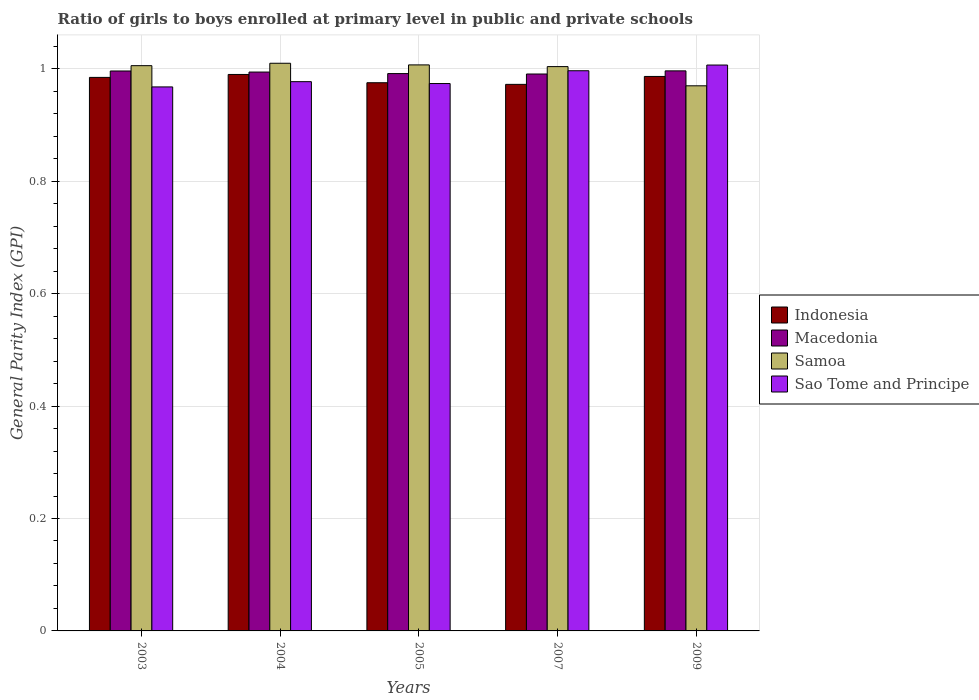How many different coloured bars are there?
Keep it short and to the point. 4. How many groups of bars are there?
Provide a succinct answer. 5. Are the number of bars on each tick of the X-axis equal?
Provide a short and direct response. Yes. How many bars are there on the 5th tick from the right?
Ensure brevity in your answer.  4. What is the label of the 5th group of bars from the left?
Keep it short and to the point. 2009. What is the general parity index in Sao Tome and Principe in 2007?
Your response must be concise. 1. Across all years, what is the maximum general parity index in Indonesia?
Offer a very short reply. 0.99. Across all years, what is the minimum general parity index in Macedonia?
Ensure brevity in your answer.  0.99. In which year was the general parity index in Samoa minimum?
Keep it short and to the point. 2009. What is the total general parity index in Indonesia in the graph?
Offer a very short reply. 4.91. What is the difference between the general parity index in Samoa in 2004 and that in 2005?
Your answer should be compact. 0. What is the difference between the general parity index in Indonesia in 2003 and the general parity index in Sao Tome and Principe in 2004?
Your answer should be very brief. 0.01. What is the average general parity index in Indonesia per year?
Your response must be concise. 0.98. In the year 2005, what is the difference between the general parity index in Sao Tome and Principe and general parity index in Samoa?
Ensure brevity in your answer.  -0.03. What is the ratio of the general parity index in Sao Tome and Principe in 2003 to that in 2004?
Your answer should be compact. 0.99. What is the difference between the highest and the second highest general parity index in Sao Tome and Principe?
Keep it short and to the point. 0.01. What is the difference between the highest and the lowest general parity index in Macedonia?
Keep it short and to the point. 0.01. In how many years, is the general parity index in Samoa greater than the average general parity index in Samoa taken over all years?
Ensure brevity in your answer.  4. What does the 4th bar from the left in 2003 represents?
Offer a terse response. Sao Tome and Principe. What does the 4th bar from the right in 2009 represents?
Give a very brief answer. Indonesia. How many bars are there?
Your answer should be compact. 20. Are all the bars in the graph horizontal?
Your answer should be very brief. No. Are the values on the major ticks of Y-axis written in scientific E-notation?
Give a very brief answer. No. Does the graph contain grids?
Give a very brief answer. Yes. How many legend labels are there?
Your answer should be very brief. 4. What is the title of the graph?
Ensure brevity in your answer.  Ratio of girls to boys enrolled at primary level in public and private schools. What is the label or title of the X-axis?
Offer a very short reply. Years. What is the label or title of the Y-axis?
Provide a short and direct response. General Parity Index (GPI). What is the General Parity Index (GPI) of Indonesia in 2003?
Make the answer very short. 0.98. What is the General Parity Index (GPI) in Macedonia in 2003?
Ensure brevity in your answer.  1. What is the General Parity Index (GPI) in Samoa in 2003?
Provide a succinct answer. 1.01. What is the General Parity Index (GPI) in Sao Tome and Principe in 2003?
Provide a short and direct response. 0.97. What is the General Parity Index (GPI) of Indonesia in 2004?
Your answer should be compact. 0.99. What is the General Parity Index (GPI) in Macedonia in 2004?
Provide a succinct answer. 0.99. What is the General Parity Index (GPI) in Samoa in 2004?
Your answer should be very brief. 1.01. What is the General Parity Index (GPI) of Sao Tome and Principe in 2004?
Provide a succinct answer. 0.98. What is the General Parity Index (GPI) of Indonesia in 2005?
Give a very brief answer. 0.98. What is the General Parity Index (GPI) of Macedonia in 2005?
Give a very brief answer. 0.99. What is the General Parity Index (GPI) of Samoa in 2005?
Offer a very short reply. 1.01. What is the General Parity Index (GPI) in Sao Tome and Principe in 2005?
Make the answer very short. 0.97. What is the General Parity Index (GPI) of Indonesia in 2007?
Offer a very short reply. 0.97. What is the General Parity Index (GPI) in Macedonia in 2007?
Keep it short and to the point. 0.99. What is the General Parity Index (GPI) in Samoa in 2007?
Offer a terse response. 1. What is the General Parity Index (GPI) of Sao Tome and Principe in 2007?
Give a very brief answer. 1. What is the General Parity Index (GPI) in Indonesia in 2009?
Your response must be concise. 0.99. What is the General Parity Index (GPI) in Macedonia in 2009?
Offer a very short reply. 1. What is the General Parity Index (GPI) of Samoa in 2009?
Your answer should be compact. 0.97. What is the General Parity Index (GPI) of Sao Tome and Principe in 2009?
Your response must be concise. 1.01. Across all years, what is the maximum General Parity Index (GPI) in Indonesia?
Offer a very short reply. 0.99. Across all years, what is the maximum General Parity Index (GPI) in Macedonia?
Provide a succinct answer. 1. Across all years, what is the maximum General Parity Index (GPI) of Samoa?
Your response must be concise. 1.01. Across all years, what is the maximum General Parity Index (GPI) of Sao Tome and Principe?
Ensure brevity in your answer.  1.01. Across all years, what is the minimum General Parity Index (GPI) in Indonesia?
Your response must be concise. 0.97. Across all years, what is the minimum General Parity Index (GPI) of Macedonia?
Keep it short and to the point. 0.99. Across all years, what is the minimum General Parity Index (GPI) of Samoa?
Provide a succinct answer. 0.97. Across all years, what is the minimum General Parity Index (GPI) of Sao Tome and Principe?
Make the answer very short. 0.97. What is the total General Parity Index (GPI) in Indonesia in the graph?
Give a very brief answer. 4.91. What is the total General Parity Index (GPI) in Macedonia in the graph?
Your answer should be very brief. 4.97. What is the total General Parity Index (GPI) of Samoa in the graph?
Make the answer very short. 5. What is the total General Parity Index (GPI) of Sao Tome and Principe in the graph?
Offer a terse response. 4.92. What is the difference between the General Parity Index (GPI) in Indonesia in 2003 and that in 2004?
Make the answer very short. -0.01. What is the difference between the General Parity Index (GPI) of Macedonia in 2003 and that in 2004?
Your answer should be compact. 0. What is the difference between the General Parity Index (GPI) of Samoa in 2003 and that in 2004?
Your answer should be very brief. -0. What is the difference between the General Parity Index (GPI) in Sao Tome and Principe in 2003 and that in 2004?
Provide a short and direct response. -0.01. What is the difference between the General Parity Index (GPI) of Indonesia in 2003 and that in 2005?
Your answer should be very brief. 0.01. What is the difference between the General Parity Index (GPI) in Macedonia in 2003 and that in 2005?
Keep it short and to the point. 0. What is the difference between the General Parity Index (GPI) of Samoa in 2003 and that in 2005?
Provide a short and direct response. -0. What is the difference between the General Parity Index (GPI) of Sao Tome and Principe in 2003 and that in 2005?
Keep it short and to the point. -0.01. What is the difference between the General Parity Index (GPI) in Indonesia in 2003 and that in 2007?
Ensure brevity in your answer.  0.01. What is the difference between the General Parity Index (GPI) in Macedonia in 2003 and that in 2007?
Give a very brief answer. 0.01. What is the difference between the General Parity Index (GPI) in Samoa in 2003 and that in 2007?
Offer a terse response. 0. What is the difference between the General Parity Index (GPI) of Sao Tome and Principe in 2003 and that in 2007?
Provide a short and direct response. -0.03. What is the difference between the General Parity Index (GPI) in Indonesia in 2003 and that in 2009?
Your answer should be very brief. -0. What is the difference between the General Parity Index (GPI) of Macedonia in 2003 and that in 2009?
Keep it short and to the point. -0. What is the difference between the General Parity Index (GPI) in Samoa in 2003 and that in 2009?
Offer a terse response. 0.04. What is the difference between the General Parity Index (GPI) of Sao Tome and Principe in 2003 and that in 2009?
Keep it short and to the point. -0.04. What is the difference between the General Parity Index (GPI) of Indonesia in 2004 and that in 2005?
Your response must be concise. 0.01. What is the difference between the General Parity Index (GPI) in Macedonia in 2004 and that in 2005?
Your response must be concise. 0. What is the difference between the General Parity Index (GPI) of Samoa in 2004 and that in 2005?
Offer a very short reply. 0. What is the difference between the General Parity Index (GPI) of Sao Tome and Principe in 2004 and that in 2005?
Your response must be concise. 0. What is the difference between the General Parity Index (GPI) of Indonesia in 2004 and that in 2007?
Offer a terse response. 0.02. What is the difference between the General Parity Index (GPI) of Macedonia in 2004 and that in 2007?
Offer a terse response. 0. What is the difference between the General Parity Index (GPI) of Samoa in 2004 and that in 2007?
Ensure brevity in your answer.  0.01. What is the difference between the General Parity Index (GPI) of Sao Tome and Principe in 2004 and that in 2007?
Make the answer very short. -0.02. What is the difference between the General Parity Index (GPI) in Indonesia in 2004 and that in 2009?
Keep it short and to the point. 0. What is the difference between the General Parity Index (GPI) in Macedonia in 2004 and that in 2009?
Keep it short and to the point. -0. What is the difference between the General Parity Index (GPI) of Samoa in 2004 and that in 2009?
Provide a succinct answer. 0.04. What is the difference between the General Parity Index (GPI) in Sao Tome and Principe in 2004 and that in 2009?
Make the answer very short. -0.03. What is the difference between the General Parity Index (GPI) in Indonesia in 2005 and that in 2007?
Offer a very short reply. 0. What is the difference between the General Parity Index (GPI) in Macedonia in 2005 and that in 2007?
Make the answer very short. 0. What is the difference between the General Parity Index (GPI) of Samoa in 2005 and that in 2007?
Ensure brevity in your answer.  0. What is the difference between the General Parity Index (GPI) of Sao Tome and Principe in 2005 and that in 2007?
Ensure brevity in your answer.  -0.02. What is the difference between the General Parity Index (GPI) in Indonesia in 2005 and that in 2009?
Provide a succinct answer. -0.01. What is the difference between the General Parity Index (GPI) in Macedonia in 2005 and that in 2009?
Your answer should be very brief. -0. What is the difference between the General Parity Index (GPI) in Samoa in 2005 and that in 2009?
Your answer should be compact. 0.04. What is the difference between the General Parity Index (GPI) of Sao Tome and Principe in 2005 and that in 2009?
Keep it short and to the point. -0.03. What is the difference between the General Parity Index (GPI) of Indonesia in 2007 and that in 2009?
Offer a very short reply. -0.01. What is the difference between the General Parity Index (GPI) in Macedonia in 2007 and that in 2009?
Offer a terse response. -0.01. What is the difference between the General Parity Index (GPI) of Samoa in 2007 and that in 2009?
Offer a terse response. 0.03. What is the difference between the General Parity Index (GPI) of Sao Tome and Principe in 2007 and that in 2009?
Keep it short and to the point. -0.01. What is the difference between the General Parity Index (GPI) in Indonesia in 2003 and the General Parity Index (GPI) in Macedonia in 2004?
Your response must be concise. -0.01. What is the difference between the General Parity Index (GPI) in Indonesia in 2003 and the General Parity Index (GPI) in Samoa in 2004?
Your answer should be compact. -0.03. What is the difference between the General Parity Index (GPI) of Indonesia in 2003 and the General Parity Index (GPI) of Sao Tome and Principe in 2004?
Offer a very short reply. 0.01. What is the difference between the General Parity Index (GPI) in Macedonia in 2003 and the General Parity Index (GPI) in Samoa in 2004?
Give a very brief answer. -0.01. What is the difference between the General Parity Index (GPI) in Macedonia in 2003 and the General Parity Index (GPI) in Sao Tome and Principe in 2004?
Your response must be concise. 0.02. What is the difference between the General Parity Index (GPI) in Samoa in 2003 and the General Parity Index (GPI) in Sao Tome and Principe in 2004?
Ensure brevity in your answer.  0.03. What is the difference between the General Parity Index (GPI) in Indonesia in 2003 and the General Parity Index (GPI) in Macedonia in 2005?
Make the answer very short. -0.01. What is the difference between the General Parity Index (GPI) in Indonesia in 2003 and the General Parity Index (GPI) in Samoa in 2005?
Offer a terse response. -0.02. What is the difference between the General Parity Index (GPI) in Indonesia in 2003 and the General Parity Index (GPI) in Sao Tome and Principe in 2005?
Your answer should be very brief. 0.01. What is the difference between the General Parity Index (GPI) in Macedonia in 2003 and the General Parity Index (GPI) in Samoa in 2005?
Your answer should be compact. -0.01. What is the difference between the General Parity Index (GPI) in Macedonia in 2003 and the General Parity Index (GPI) in Sao Tome and Principe in 2005?
Provide a short and direct response. 0.02. What is the difference between the General Parity Index (GPI) of Samoa in 2003 and the General Parity Index (GPI) of Sao Tome and Principe in 2005?
Offer a very short reply. 0.03. What is the difference between the General Parity Index (GPI) in Indonesia in 2003 and the General Parity Index (GPI) in Macedonia in 2007?
Provide a short and direct response. -0.01. What is the difference between the General Parity Index (GPI) in Indonesia in 2003 and the General Parity Index (GPI) in Samoa in 2007?
Provide a short and direct response. -0.02. What is the difference between the General Parity Index (GPI) in Indonesia in 2003 and the General Parity Index (GPI) in Sao Tome and Principe in 2007?
Your answer should be very brief. -0.01. What is the difference between the General Parity Index (GPI) of Macedonia in 2003 and the General Parity Index (GPI) of Samoa in 2007?
Make the answer very short. -0.01. What is the difference between the General Parity Index (GPI) of Macedonia in 2003 and the General Parity Index (GPI) of Sao Tome and Principe in 2007?
Provide a short and direct response. -0. What is the difference between the General Parity Index (GPI) in Samoa in 2003 and the General Parity Index (GPI) in Sao Tome and Principe in 2007?
Your response must be concise. 0.01. What is the difference between the General Parity Index (GPI) in Indonesia in 2003 and the General Parity Index (GPI) in Macedonia in 2009?
Offer a very short reply. -0.01. What is the difference between the General Parity Index (GPI) of Indonesia in 2003 and the General Parity Index (GPI) of Samoa in 2009?
Ensure brevity in your answer.  0.01. What is the difference between the General Parity Index (GPI) in Indonesia in 2003 and the General Parity Index (GPI) in Sao Tome and Principe in 2009?
Provide a succinct answer. -0.02. What is the difference between the General Parity Index (GPI) in Macedonia in 2003 and the General Parity Index (GPI) in Samoa in 2009?
Provide a succinct answer. 0.03. What is the difference between the General Parity Index (GPI) of Macedonia in 2003 and the General Parity Index (GPI) of Sao Tome and Principe in 2009?
Offer a very short reply. -0.01. What is the difference between the General Parity Index (GPI) of Samoa in 2003 and the General Parity Index (GPI) of Sao Tome and Principe in 2009?
Your response must be concise. -0. What is the difference between the General Parity Index (GPI) of Indonesia in 2004 and the General Parity Index (GPI) of Macedonia in 2005?
Keep it short and to the point. -0. What is the difference between the General Parity Index (GPI) of Indonesia in 2004 and the General Parity Index (GPI) of Samoa in 2005?
Provide a short and direct response. -0.02. What is the difference between the General Parity Index (GPI) of Indonesia in 2004 and the General Parity Index (GPI) of Sao Tome and Principe in 2005?
Your response must be concise. 0.02. What is the difference between the General Parity Index (GPI) of Macedonia in 2004 and the General Parity Index (GPI) of Samoa in 2005?
Your answer should be compact. -0.01. What is the difference between the General Parity Index (GPI) in Macedonia in 2004 and the General Parity Index (GPI) in Sao Tome and Principe in 2005?
Your answer should be compact. 0.02. What is the difference between the General Parity Index (GPI) in Samoa in 2004 and the General Parity Index (GPI) in Sao Tome and Principe in 2005?
Your answer should be very brief. 0.04. What is the difference between the General Parity Index (GPI) in Indonesia in 2004 and the General Parity Index (GPI) in Macedonia in 2007?
Provide a short and direct response. -0. What is the difference between the General Parity Index (GPI) in Indonesia in 2004 and the General Parity Index (GPI) in Samoa in 2007?
Provide a short and direct response. -0.01. What is the difference between the General Parity Index (GPI) of Indonesia in 2004 and the General Parity Index (GPI) of Sao Tome and Principe in 2007?
Provide a short and direct response. -0.01. What is the difference between the General Parity Index (GPI) of Macedonia in 2004 and the General Parity Index (GPI) of Samoa in 2007?
Give a very brief answer. -0.01. What is the difference between the General Parity Index (GPI) of Macedonia in 2004 and the General Parity Index (GPI) of Sao Tome and Principe in 2007?
Your answer should be very brief. -0. What is the difference between the General Parity Index (GPI) in Samoa in 2004 and the General Parity Index (GPI) in Sao Tome and Principe in 2007?
Provide a short and direct response. 0.01. What is the difference between the General Parity Index (GPI) of Indonesia in 2004 and the General Parity Index (GPI) of Macedonia in 2009?
Make the answer very short. -0.01. What is the difference between the General Parity Index (GPI) in Indonesia in 2004 and the General Parity Index (GPI) in Samoa in 2009?
Your answer should be very brief. 0.02. What is the difference between the General Parity Index (GPI) in Indonesia in 2004 and the General Parity Index (GPI) in Sao Tome and Principe in 2009?
Your response must be concise. -0.02. What is the difference between the General Parity Index (GPI) of Macedonia in 2004 and the General Parity Index (GPI) of Samoa in 2009?
Offer a terse response. 0.02. What is the difference between the General Parity Index (GPI) of Macedonia in 2004 and the General Parity Index (GPI) of Sao Tome and Principe in 2009?
Provide a short and direct response. -0.01. What is the difference between the General Parity Index (GPI) of Samoa in 2004 and the General Parity Index (GPI) of Sao Tome and Principe in 2009?
Keep it short and to the point. 0. What is the difference between the General Parity Index (GPI) of Indonesia in 2005 and the General Parity Index (GPI) of Macedonia in 2007?
Make the answer very short. -0.02. What is the difference between the General Parity Index (GPI) of Indonesia in 2005 and the General Parity Index (GPI) of Samoa in 2007?
Make the answer very short. -0.03. What is the difference between the General Parity Index (GPI) of Indonesia in 2005 and the General Parity Index (GPI) of Sao Tome and Principe in 2007?
Provide a succinct answer. -0.02. What is the difference between the General Parity Index (GPI) in Macedonia in 2005 and the General Parity Index (GPI) in Samoa in 2007?
Your response must be concise. -0.01. What is the difference between the General Parity Index (GPI) of Macedonia in 2005 and the General Parity Index (GPI) of Sao Tome and Principe in 2007?
Provide a short and direct response. -0.01. What is the difference between the General Parity Index (GPI) in Samoa in 2005 and the General Parity Index (GPI) in Sao Tome and Principe in 2007?
Make the answer very short. 0.01. What is the difference between the General Parity Index (GPI) of Indonesia in 2005 and the General Parity Index (GPI) of Macedonia in 2009?
Provide a short and direct response. -0.02. What is the difference between the General Parity Index (GPI) of Indonesia in 2005 and the General Parity Index (GPI) of Samoa in 2009?
Keep it short and to the point. 0.01. What is the difference between the General Parity Index (GPI) in Indonesia in 2005 and the General Parity Index (GPI) in Sao Tome and Principe in 2009?
Make the answer very short. -0.03. What is the difference between the General Parity Index (GPI) of Macedonia in 2005 and the General Parity Index (GPI) of Samoa in 2009?
Your answer should be compact. 0.02. What is the difference between the General Parity Index (GPI) in Macedonia in 2005 and the General Parity Index (GPI) in Sao Tome and Principe in 2009?
Make the answer very short. -0.02. What is the difference between the General Parity Index (GPI) in Samoa in 2005 and the General Parity Index (GPI) in Sao Tome and Principe in 2009?
Keep it short and to the point. 0. What is the difference between the General Parity Index (GPI) in Indonesia in 2007 and the General Parity Index (GPI) in Macedonia in 2009?
Make the answer very short. -0.02. What is the difference between the General Parity Index (GPI) in Indonesia in 2007 and the General Parity Index (GPI) in Samoa in 2009?
Give a very brief answer. 0. What is the difference between the General Parity Index (GPI) of Indonesia in 2007 and the General Parity Index (GPI) of Sao Tome and Principe in 2009?
Offer a terse response. -0.03. What is the difference between the General Parity Index (GPI) of Macedonia in 2007 and the General Parity Index (GPI) of Samoa in 2009?
Make the answer very short. 0.02. What is the difference between the General Parity Index (GPI) of Macedonia in 2007 and the General Parity Index (GPI) of Sao Tome and Principe in 2009?
Ensure brevity in your answer.  -0.02. What is the difference between the General Parity Index (GPI) in Samoa in 2007 and the General Parity Index (GPI) in Sao Tome and Principe in 2009?
Provide a short and direct response. -0. What is the average General Parity Index (GPI) of Indonesia per year?
Keep it short and to the point. 0.98. What is the average General Parity Index (GPI) of Macedonia per year?
Offer a very short reply. 0.99. What is the average General Parity Index (GPI) in Samoa per year?
Offer a very short reply. 1. What is the average General Parity Index (GPI) of Sao Tome and Principe per year?
Your answer should be compact. 0.98. In the year 2003, what is the difference between the General Parity Index (GPI) of Indonesia and General Parity Index (GPI) of Macedonia?
Provide a succinct answer. -0.01. In the year 2003, what is the difference between the General Parity Index (GPI) of Indonesia and General Parity Index (GPI) of Samoa?
Give a very brief answer. -0.02. In the year 2003, what is the difference between the General Parity Index (GPI) in Indonesia and General Parity Index (GPI) in Sao Tome and Principe?
Your answer should be very brief. 0.02. In the year 2003, what is the difference between the General Parity Index (GPI) of Macedonia and General Parity Index (GPI) of Samoa?
Offer a very short reply. -0.01. In the year 2003, what is the difference between the General Parity Index (GPI) in Macedonia and General Parity Index (GPI) in Sao Tome and Principe?
Your answer should be compact. 0.03. In the year 2003, what is the difference between the General Parity Index (GPI) in Samoa and General Parity Index (GPI) in Sao Tome and Principe?
Make the answer very short. 0.04. In the year 2004, what is the difference between the General Parity Index (GPI) of Indonesia and General Parity Index (GPI) of Macedonia?
Offer a terse response. -0. In the year 2004, what is the difference between the General Parity Index (GPI) in Indonesia and General Parity Index (GPI) in Samoa?
Ensure brevity in your answer.  -0.02. In the year 2004, what is the difference between the General Parity Index (GPI) in Indonesia and General Parity Index (GPI) in Sao Tome and Principe?
Provide a succinct answer. 0.01. In the year 2004, what is the difference between the General Parity Index (GPI) in Macedonia and General Parity Index (GPI) in Samoa?
Ensure brevity in your answer.  -0.02. In the year 2004, what is the difference between the General Parity Index (GPI) in Macedonia and General Parity Index (GPI) in Sao Tome and Principe?
Offer a very short reply. 0.02. In the year 2004, what is the difference between the General Parity Index (GPI) of Samoa and General Parity Index (GPI) of Sao Tome and Principe?
Your answer should be compact. 0.03. In the year 2005, what is the difference between the General Parity Index (GPI) of Indonesia and General Parity Index (GPI) of Macedonia?
Your response must be concise. -0.02. In the year 2005, what is the difference between the General Parity Index (GPI) in Indonesia and General Parity Index (GPI) in Samoa?
Provide a succinct answer. -0.03. In the year 2005, what is the difference between the General Parity Index (GPI) in Indonesia and General Parity Index (GPI) in Sao Tome and Principe?
Your answer should be very brief. 0. In the year 2005, what is the difference between the General Parity Index (GPI) in Macedonia and General Parity Index (GPI) in Samoa?
Your answer should be compact. -0.02. In the year 2005, what is the difference between the General Parity Index (GPI) of Macedonia and General Parity Index (GPI) of Sao Tome and Principe?
Make the answer very short. 0.02. In the year 2005, what is the difference between the General Parity Index (GPI) of Samoa and General Parity Index (GPI) of Sao Tome and Principe?
Offer a terse response. 0.03. In the year 2007, what is the difference between the General Parity Index (GPI) in Indonesia and General Parity Index (GPI) in Macedonia?
Make the answer very short. -0.02. In the year 2007, what is the difference between the General Parity Index (GPI) of Indonesia and General Parity Index (GPI) of Samoa?
Your answer should be very brief. -0.03. In the year 2007, what is the difference between the General Parity Index (GPI) in Indonesia and General Parity Index (GPI) in Sao Tome and Principe?
Offer a terse response. -0.02. In the year 2007, what is the difference between the General Parity Index (GPI) of Macedonia and General Parity Index (GPI) of Samoa?
Your answer should be compact. -0.01. In the year 2007, what is the difference between the General Parity Index (GPI) of Macedonia and General Parity Index (GPI) of Sao Tome and Principe?
Offer a terse response. -0.01. In the year 2007, what is the difference between the General Parity Index (GPI) in Samoa and General Parity Index (GPI) in Sao Tome and Principe?
Give a very brief answer. 0.01. In the year 2009, what is the difference between the General Parity Index (GPI) in Indonesia and General Parity Index (GPI) in Macedonia?
Ensure brevity in your answer.  -0.01. In the year 2009, what is the difference between the General Parity Index (GPI) in Indonesia and General Parity Index (GPI) in Samoa?
Ensure brevity in your answer.  0.02. In the year 2009, what is the difference between the General Parity Index (GPI) of Indonesia and General Parity Index (GPI) of Sao Tome and Principe?
Ensure brevity in your answer.  -0.02. In the year 2009, what is the difference between the General Parity Index (GPI) in Macedonia and General Parity Index (GPI) in Samoa?
Provide a short and direct response. 0.03. In the year 2009, what is the difference between the General Parity Index (GPI) of Macedonia and General Parity Index (GPI) of Sao Tome and Principe?
Give a very brief answer. -0.01. In the year 2009, what is the difference between the General Parity Index (GPI) of Samoa and General Parity Index (GPI) of Sao Tome and Principe?
Ensure brevity in your answer.  -0.04. What is the ratio of the General Parity Index (GPI) in Macedonia in 2003 to that in 2004?
Your answer should be very brief. 1. What is the ratio of the General Parity Index (GPI) of Sao Tome and Principe in 2003 to that in 2004?
Offer a very short reply. 0.99. What is the ratio of the General Parity Index (GPI) in Indonesia in 2003 to that in 2005?
Offer a terse response. 1.01. What is the ratio of the General Parity Index (GPI) of Macedonia in 2003 to that in 2005?
Provide a succinct answer. 1. What is the ratio of the General Parity Index (GPI) in Indonesia in 2003 to that in 2007?
Offer a very short reply. 1.01. What is the ratio of the General Parity Index (GPI) of Macedonia in 2003 to that in 2007?
Provide a short and direct response. 1.01. What is the ratio of the General Parity Index (GPI) of Sao Tome and Principe in 2003 to that in 2007?
Your response must be concise. 0.97. What is the ratio of the General Parity Index (GPI) in Indonesia in 2003 to that in 2009?
Your response must be concise. 1. What is the ratio of the General Parity Index (GPI) of Macedonia in 2003 to that in 2009?
Offer a very short reply. 1. What is the ratio of the General Parity Index (GPI) of Samoa in 2003 to that in 2009?
Give a very brief answer. 1.04. What is the ratio of the General Parity Index (GPI) of Sao Tome and Principe in 2003 to that in 2009?
Your answer should be compact. 0.96. What is the ratio of the General Parity Index (GPI) in Indonesia in 2004 to that in 2005?
Provide a succinct answer. 1.02. What is the ratio of the General Parity Index (GPI) of Macedonia in 2004 to that in 2005?
Your answer should be very brief. 1. What is the ratio of the General Parity Index (GPI) of Samoa in 2004 to that in 2005?
Ensure brevity in your answer.  1. What is the ratio of the General Parity Index (GPI) of Sao Tome and Principe in 2004 to that in 2005?
Give a very brief answer. 1. What is the ratio of the General Parity Index (GPI) in Indonesia in 2004 to that in 2007?
Offer a very short reply. 1.02. What is the ratio of the General Parity Index (GPI) of Macedonia in 2004 to that in 2007?
Give a very brief answer. 1. What is the ratio of the General Parity Index (GPI) in Samoa in 2004 to that in 2007?
Your answer should be compact. 1.01. What is the ratio of the General Parity Index (GPI) of Sao Tome and Principe in 2004 to that in 2007?
Ensure brevity in your answer.  0.98. What is the ratio of the General Parity Index (GPI) in Samoa in 2004 to that in 2009?
Make the answer very short. 1.04. What is the ratio of the General Parity Index (GPI) in Sao Tome and Principe in 2004 to that in 2009?
Offer a very short reply. 0.97. What is the ratio of the General Parity Index (GPI) of Indonesia in 2005 to that in 2007?
Your response must be concise. 1. What is the ratio of the General Parity Index (GPI) of Samoa in 2005 to that in 2007?
Offer a terse response. 1. What is the ratio of the General Parity Index (GPI) of Sao Tome and Principe in 2005 to that in 2007?
Keep it short and to the point. 0.98. What is the ratio of the General Parity Index (GPI) of Indonesia in 2005 to that in 2009?
Give a very brief answer. 0.99. What is the ratio of the General Parity Index (GPI) in Samoa in 2005 to that in 2009?
Offer a terse response. 1.04. What is the ratio of the General Parity Index (GPI) in Sao Tome and Principe in 2005 to that in 2009?
Offer a very short reply. 0.97. What is the ratio of the General Parity Index (GPI) in Indonesia in 2007 to that in 2009?
Your response must be concise. 0.99. What is the ratio of the General Parity Index (GPI) of Macedonia in 2007 to that in 2009?
Give a very brief answer. 0.99. What is the ratio of the General Parity Index (GPI) of Samoa in 2007 to that in 2009?
Your response must be concise. 1.04. What is the ratio of the General Parity Index (GPI) in Sao Tome and Principe in 2007 to that in 2009?
Keep it short and to the point. 0.99. What is the difference between the highest and the second highest General Parity Index (GPI) in Indonesia?
Provide a succinct answer. 0. What is the difference between the highest and the second highest General Parity Index (GPI) of Samoa?
Keep it short and to the point. 0. What is the difference between the highest and the second highest General Parity Index (GPI) in Sao Tome and Principe?
Provide a short and direct response. 0.01. What is the difference between the highest and the lowest General Parity Index (GPI) in Indonesia?
Provide a short and direct response. 0.02. What is the difference between the highest and the lowest General Parity Index (GPI) of Macedonia?
Make the answer very short. 0.01. What is the difference between the highest and the lowest General Parity Index (GPI) of Samoa?
Give a very brief answer. 0.04. What is the difference between the highest and the lowest General Parity Index (GPI) in Sao Tome and Principe?
Give a very brief answer. 0.04. 